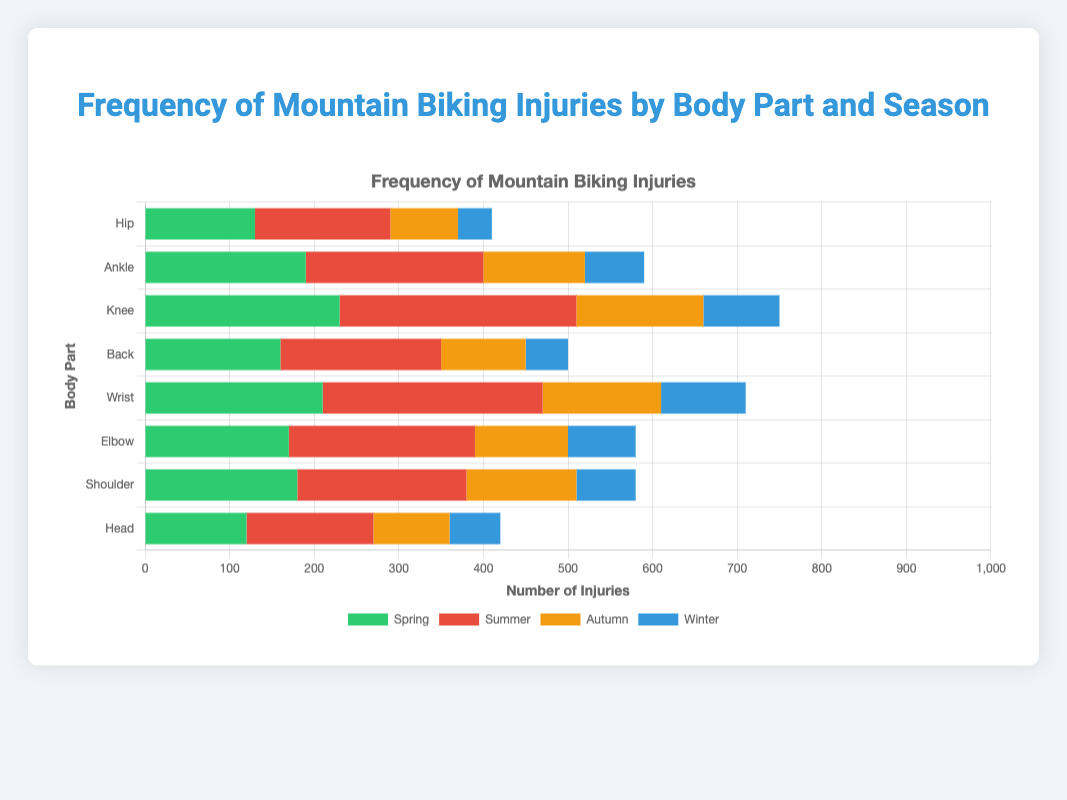Which body part has the highest number of injuries in summer? To answer this, we look at the length of the red bars as they represent the summer season. The body part with the longest red bar is "Knee".
Answer: Knee During which season do wrist injuries occur most frequently? Identify the wrist body part and observe the longest bar corresponding to it across different seasons. The longest bar for the wrist is red, representing summer.
Answer: Summer What is the total number of injuries for the ankle during spring and autumn? Locate the green (spring) and orange (autumn) bars for the ankle. Sum the lengths of these bars: 190 (spring) + 120 (autumn) = 310.
Answer: 310 Which season has the least number of head injuries? Look for the shortest bar in each color category representing the head. The shortest bar is blue, representing winter.
Answer: Winter Compare the number of hip injuries in spring to those in autumn. Which one is greater, and by how much? Locate the green (spring) and orange (autumn) bars for the hip. The values are 130 (spring) and 80 (autumn). Spring has more injuries by 130 - 80 = 50.
Answer: Spring, by 50 What is the average number of knee injuries across all seasons? Sum the lengths of all the bars for the knee and divide by the number of seasons: (230 + 280 + 150 + 90) / 4 = 750 / 4 = 187.5.
Answer: 187.5 Which body part has the least number of injuries in winter? Identify the shortest blue bar, which represents winter. The shortest blue bar is for the hip.
Answer: Hip How many more elbow injuries occur in summer compared to winter? Look at the red (summer) and blue (winter) bars for the elbow. Summer has 220 injuries and winter has 80. The difference is 220 - 80 = 140.
Answer: 140 Are back injuries more frequent in spring or autumn, and by how much? Compare the lengths of the green (spring) and orange (autumn) bars for the back. The values are 160 (spring) and 100 (autumn). Spring has more injuries by 160 - 100 = 60.
Answer: Spring, by 60 What is the total number of shoulder injuries in winter and spring combined? Add the values for the shoulder in the green (spring) and blue (winter) bars: 180 (spring) + 70 (winter) = 250.
Answer: 250 